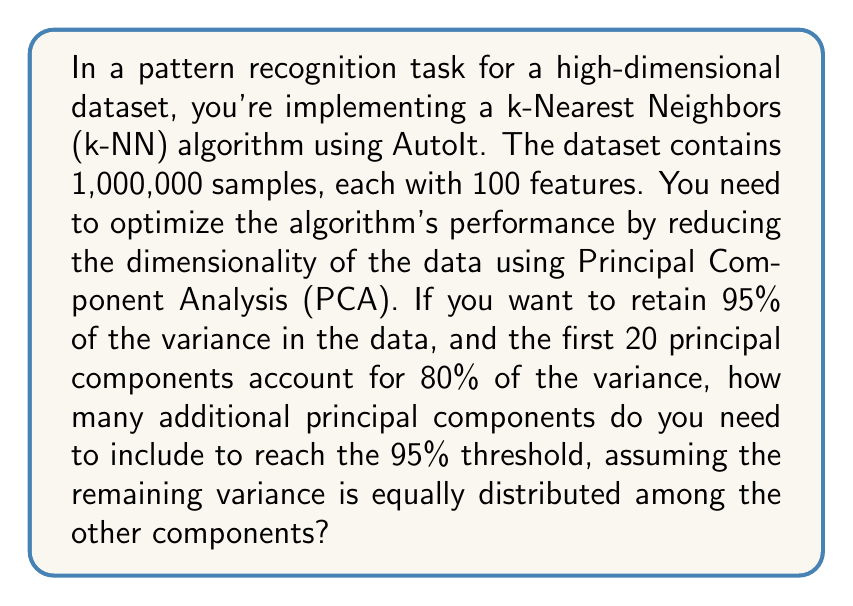Could you help me with this problem? To solve this problem, let's break it down into steps:

1. Understand the given information:
   - Total variance to retain: 95%
   - Variance accounted for by first 20 components: 80%
   - Remaining variance to account for: 95% - 80% = 15%
   - Total number of features: 100
   - Remaining components: 100 - 20 = 80

2. Calculate the variance per remaining component:
   Let $x$ be the variance per remaining component.
   Total remaining variance = Number of remaining components * Variance per component
   $20\% = 80x$
   $x = \frac{20\%}{80} = 0.25\%$

3. Calculate the number of additional components needed:
   Let $n$ be the number of additional components.
   Variance from additional components = 15%
   $0.25\% * n = 15\%$
   $n = \frac{15\%}{0.25\%} = 60$

Therefore, you need to include 60 additional principal components to reach the 95% variance threshold.

4. Verify the result:
   - Variance from first 20 components: 80%
   - Variance from additional 60 components: $60 * 0.25\% = 15\%$
   - Total variance: $80\% + 15\% = 95\%$

This confirms that including 60 additional principal components will reach the desired 95% variance threshold.
Answer: 60 additional principal components 